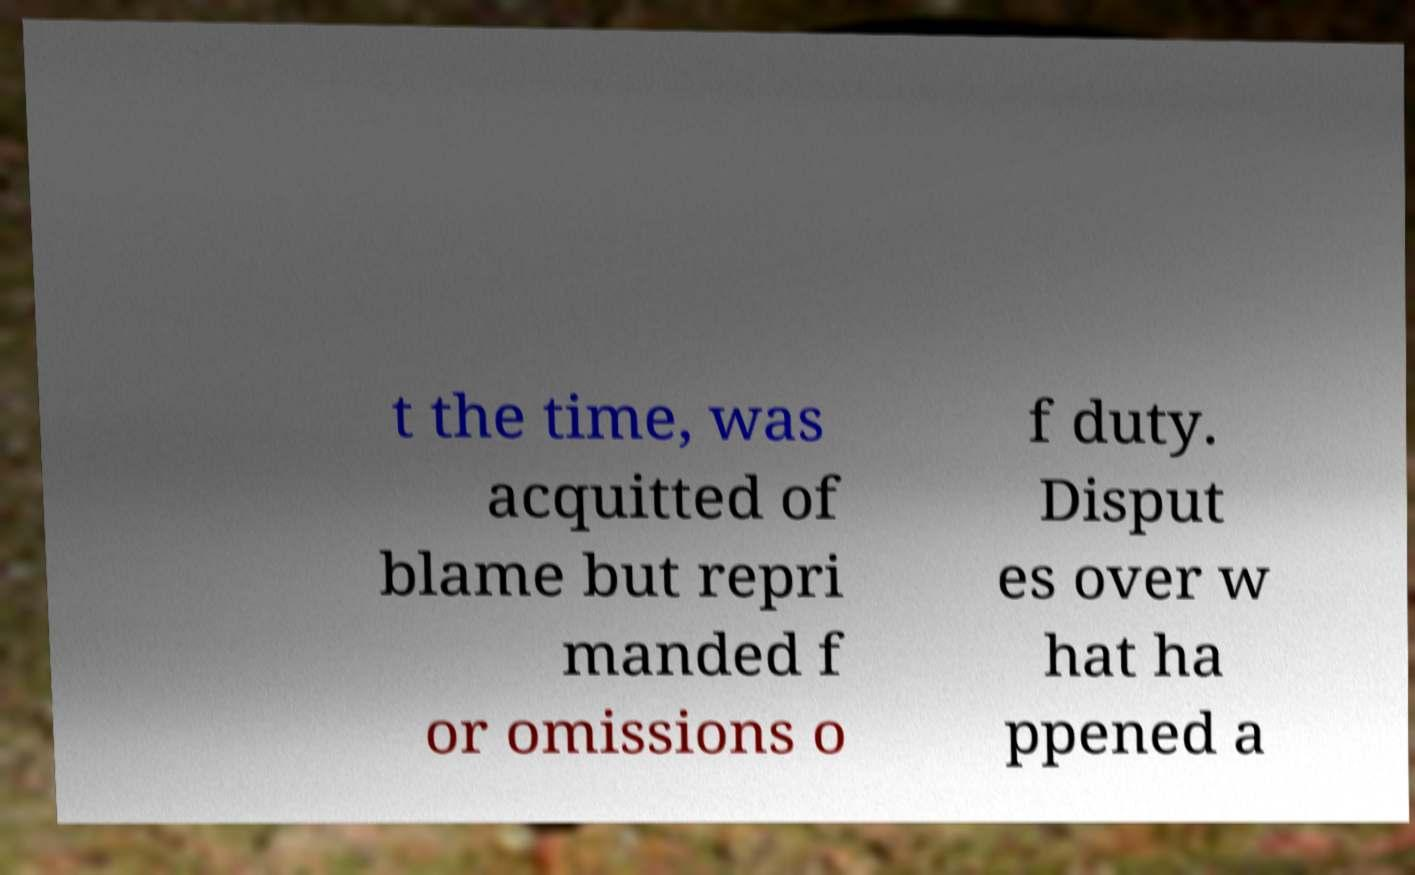For documentation purposes, I need the text within this image transcribed. Could you provide that? t the time, was acquitted of blame but repri manded f or omissions o f duty. Disput es over w hat ha ppened a 